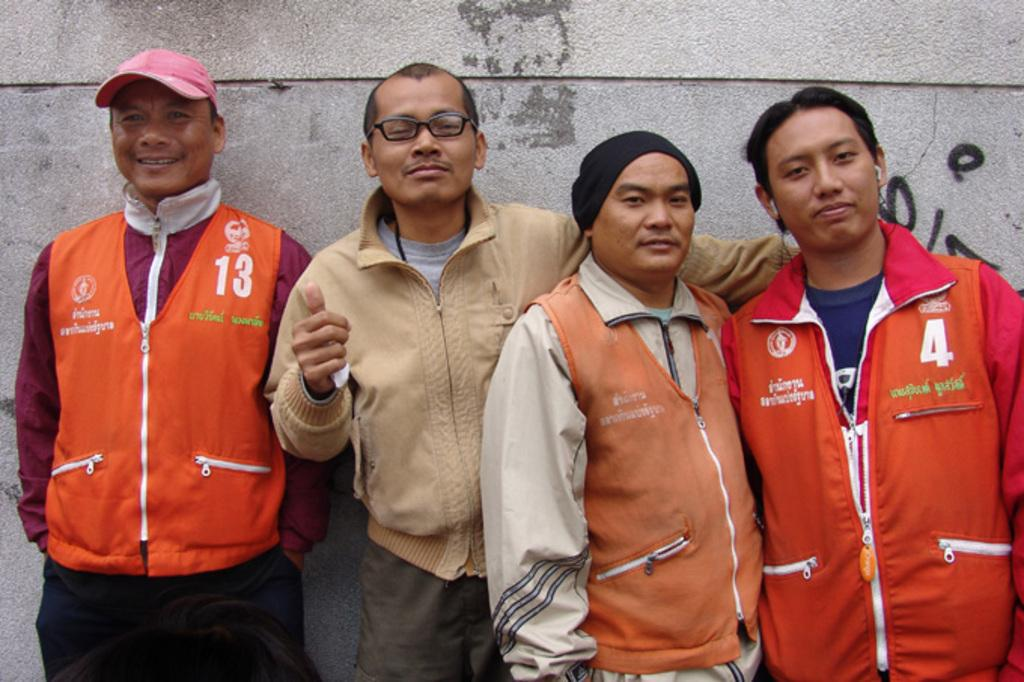<image>
Relay a brief, clear account of the picture shown. The man in the 13 jacket stands slight apart from the other 3 men against the wall. 